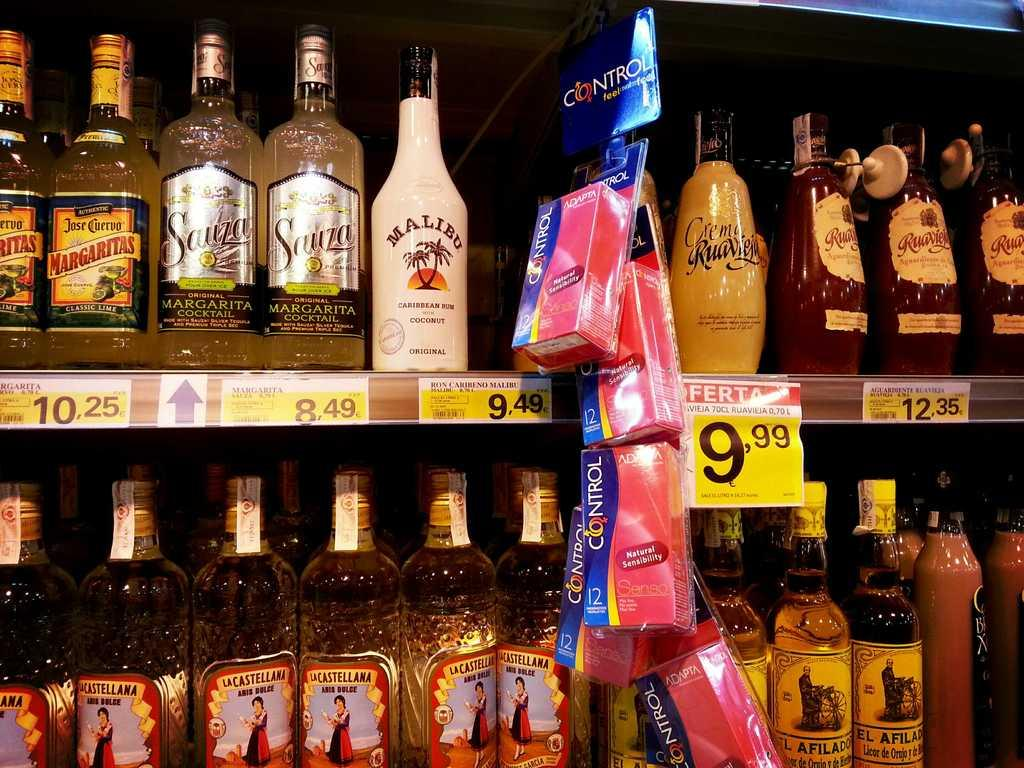Provide a one-sentence caption for the provided image. A liquor shelf at a supermarket with bottles including a bottle of Malibu rum. 